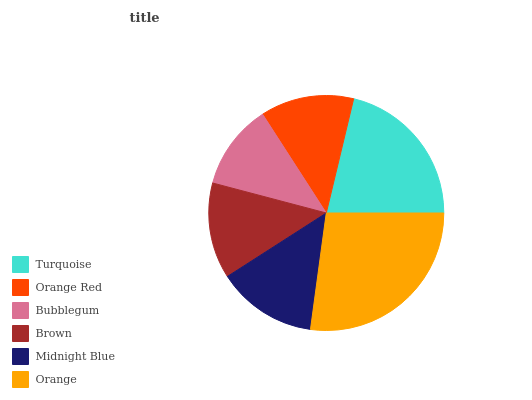Is Bubblegum the minimum?
Answer yes or no. Yes. Is Orange the maximum?
Answer yes or no. Yes. Is Orange Red the minimum?
Answer yes or no. No. Is Orange Red the maximum?
Answer yes or no. No. Is Turquoise greater than Orange Red?
Answer yes or no. Yes. Is Orange Red less than Turquoise?
Answer yes or no. Yes. Is Orange Red greater than Turquoise?
Answer yes or no. No. Is Turquoise less than Orange Red?
Answer yes or no. No. Is Midnight Blue the high median?
Answer yes or no. Yes. Is Brown the low median?
Answer yes or no. Yes. Is Orange the high median?
Answer yes or no. No. Is Bubblegum the low median?
Answer yes or no. No. 